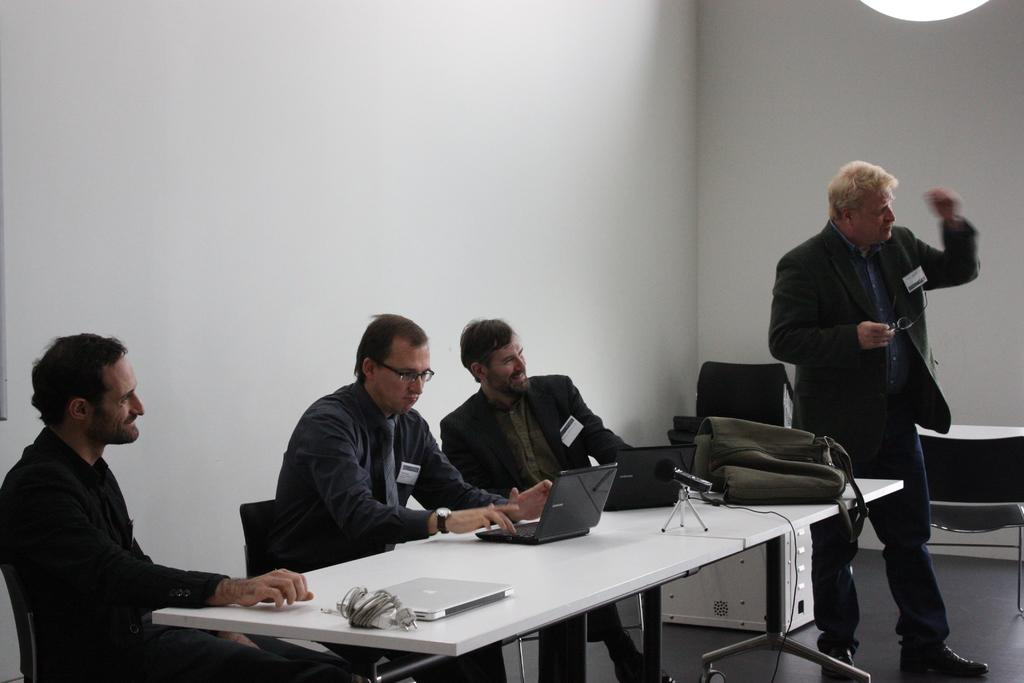What is the color of the wall in the image? There is a white wall in the image. What are the people wearing in the image? The people in the image are wearing black jackets. What type of furniture is present in the image? There are chairs and tables in the image. What electronic devices can be seen on the table? There are laptops on the table. What else is on the table besides the laptops? There is a bag on the table. What type of sound can be heard coming from the bag on the table? There is no sound coming from the bag on the table in the image. How many babies are present in the image? There are no babies present in the image. What type of potato is visible on the table? There is no potato present in the image. 